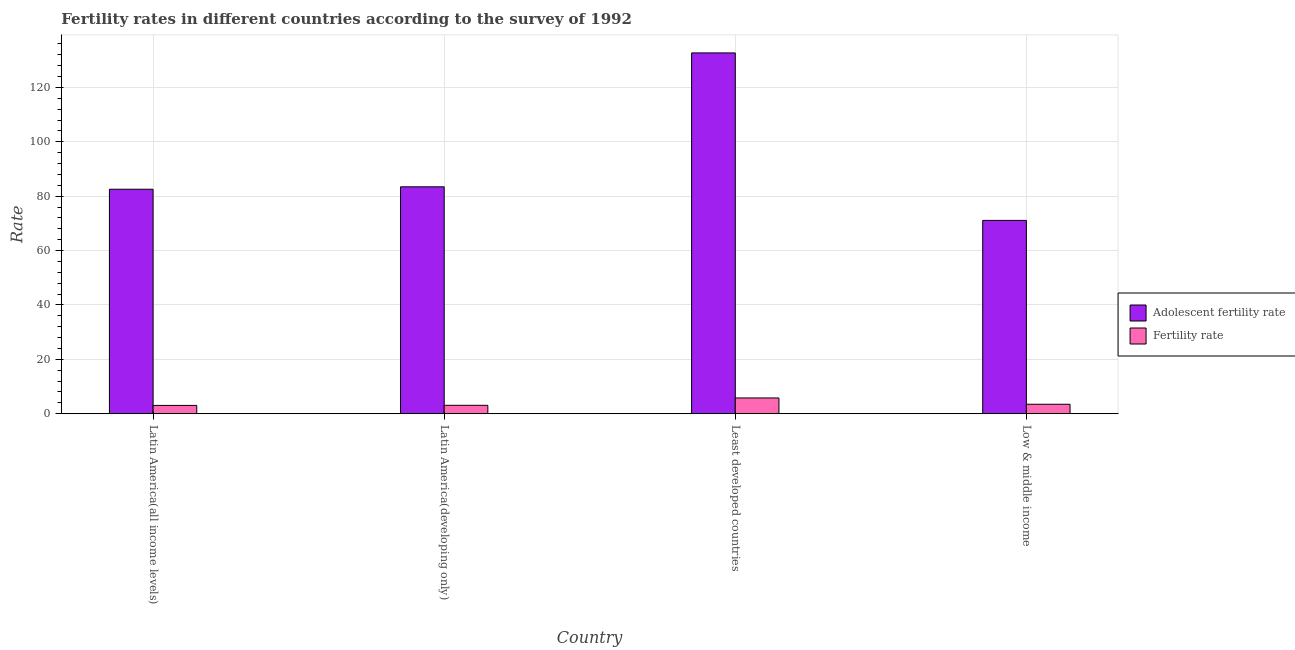Are the number of bars on each tick of the X-axis equal?
Provide a succinct answer. Yes. How many bars are there on the 3rd tick from the left?
Offer a terse response. 2. What is the label of the 2nd group of bars from the left?
Offer a very short reply. Latin America(developing only). In how many cases, is the number of bars for a given country not equal to the number of legend labels?
Give a very brief answer. 0. What is the adolescent fertility rate in Least developed countries?
Your response must be concise. 132.71. Across all countries, what is the maximum fertility rate?
Ensure brevity in your answer.  5.8. Across all countries, what is the minimum fertility rate?
Ensure brevity in your answer.  3.06. In which country was the fertility rate maximum?
Your response must be concise. Least developed countries. What is the total adolescent fertility rate in the graph?
Make the answer very short. 369.84. What is the difference between the fertility rate in Latin America(developing only) and that in Low & middle income?
Keep it short and to the point. -0.39. What is the difference between the adolescent fertility rate in Latin America(developing only) and the fertility rate in Low & middle income?
Ensure brevity in your answer.  79.97. What is the average adolescent fertility rate per country?
Give a very brief answer. 92.46. What is the difference between the fertility rate and adolescent fertility rate in Latin America(all income levels)?
Make the answer very short. -79.51. In how many countries, is the fertility rate greater than 40 ?
Provide a short and direct response. 0. What is the ratio of the fertility rate in Latin America(developing only) to that in Least developed countries?
Provide a succinct answer. 0.53. Is the fertility rate in Latin America(developing only) less than that in Least developed countries?
Provide a short and direct response. Yes. What is the difference between the highest and the second highest fertility rate?
Ensure brevity in your answer.  2.31. What is the difference between the highest and the lowest adolescent fertility rate?
Offer a very short reply. 61.6. Is the sum of the adolescent fertility rate in Latin America(developing only) and Least developed countries greater than the maximum fertility rate across all countries?
Your answer should be very brief. Yes. What does the 2nd bar from the left in Latin America(all income levels) represents?
Your answer should be compact. Fertility rate. What does the 1st bar from the right in Least developed countries represents?
Your answer should be very brief. Fertility rate. How many countries are there in the graph?
Your answer should be compact. 4. What is the difference between two consecutive major ticks on the Y-axis?
Your answer should be very brief. 20. Does the graph contain any zero values?
Provide a short and direct response. No. Does the graph contain grids?
Give a very brief answer. Yes. Where does the legend appear in the graph?
Your response must be concise. Center right. How many legend labels are there?
Offer a very short reply. 2. How are the legend labels stacked?
Make the answer very short. Vertical. What is the title of the graph?
Provide a short and direct response. Fertility rates in different countries according to the survey of 1992. Does "Formally registered" appear as one of the legend labels in the graph?
Offer a very short reply. No. What is the label or title of the X-axis?
Make the answer very short. Country. What is the label or title of the Y-axis?
Ensure brevity in your answer.  Rate. What is the Rate of Adolescent fertility rate in Latin America(all income levels)?
Provide a succinct answer. 82.57. What is the Rate in Fertility rate in Latin America(all income levels)?
Offer a very short reply. 3.06. What is the Rate in Adolescent fertility rate in Latin America(developing only)?
Provide a short and direct response. 83.46. What is the Rate in Fertility rate in Latin America(developing only)?
Give a very brief answer. 3.1. What is the Rate of Adolescent fertility rate in Least developed countries?
Offer a very short reply. 132.71. What is the Rate of Fertility rate in Least developed countries?
Keep it short and to the point. 5.8. What is the Rate in Adolescent fertility rate in Low & middle income?
Offer a terse response. 71.11. What is the Rate in Fertility rate in Low & middle income?
Your answer should be very brief. 3.49. Across all countries, what is the maximum Rate in Adolescent fertility rate?
Your response must be concise. 132.71. Across all countries, what is the maximum Rate of Fertility rate?
Your answer should be very brief. 5.8. Across all countries, what is the minimum Rate of Adolescent fertility rate?
Ensure brevity in your answer.  71.11. Across all countries, what is the minimum Rate of Fertility rate?
Offer a terse response. 3.06. What is the total Rate of Adolescent fertility rate in the graph?
Keep it short and to the point. 369.84. What is the total Rate in Fertility rate in the graph?
Offer a terse response. 15.45. What is the difference between the Rate in Adolescent fertility rate in Latin America(all income levels) and that in Latin America(developing only)?
Make the answer very short. -0.89. What is the difference between the Rate in Fertility rate in Latin America(all income levels) and that in Latin America(developing only)?
Give a very brief answer. -0.04. What is the difference between the Rate in Adolescent fertility rate in Latin America(all income levels) and that in Least developed countries?
Provide a succinct answer. -50.14. What is the difference between the Rate in Fertility rate in Latin America(all income levels) and that in Least developed countries?
Keep it short and to the point. -2.74. What is the difference between the Rate in Adolescent fertility rate in Latin America(all income levels) and that in Low & middle income?
Your response must be concise. 11.46. What is the difference between the Rate of Fertility rate in Latin America(all income levels) and that in Low & middle income?
Your answer should be compact. -0.43. What is the difference between the Rate of Adolescent fertility rate in Latin America(developing only) and that in Least developed countries?
Your response must be concise. -49.25. What is the difference between the Rate in Fertility rate in Latin America(developing only) and that in Least developed countries?
Provide a short and direct response. -2.7. What is the difference between the Rate in Adolescent fertility rate in Latin America(developing only) and that in Low & middle income?
Your response must be concise. 12.35. What is the difference between the Rate in Fertility rate in Latin America(developing only) and that in Low & middle income?
Offer a terse response. -0.39. What is the difference between the Rate of Adolescent fertility rate in Least developed countries and that in Low & middle income?
Your answer should be compact. 61.6. What is the difference between the Rate in Fertility rate in Least developed countries and that in Low & middle income?
Offer a terse response. 2.31. What is the difference between the Rate of Adolescent fertility rate in Latin America(all income levels) and the Rate of Fertility rate in Latin America(developing only)?
Provide a succinct answer. 79.47. What is the difference between the Rate of Adolescent fertility rate in Latin America(all income levels) and the Rate of Fertility rate in Least developed countries?
Keep it short and to the point. 76.76. What is the difference between the Rate in Adolescent fertility rate in Latin America(all income levels) and the Rate in Fertility rate in Low & middle income?
Offer a very short reply. 79.08. What is the difference between the Rate in Adolescent fertility rate in Latin America(developing only) and the Rate in Fertility rate in Least developed countries?
Offer a terse response. 77.66. What is the difference between the Rate of Adolescent fertility rate in Latin America(developing only) and the Rate of Fertility rate in Low & middle income?
Your response must be concise. 79.97. What is the difference between the Rate in Adolescent fertility rate in Least developed countries and the Rate in Fertility rate in Low & middle income?
Your response must be concise. 129.22. What is the average Rate in Adolescent fertility rate per country?
Your answer should be compact. 92.46. What is the average Rate of Fertility rate per country?
Ensure brevity in your answer.  3.86. What is the difference between the Rate of Adolescent fertility rate and Rate of Fertility rate in Latin America(all income levels)?
Offer a very short reply. 79.51. What is the difference between the Rate of Adolescent fertility rate and Rate of Fertility rate in Latin America(developing only)?
Provide a short and direct response. 80.36. What is the difference between the Rate in Adolescent fertility rate and Rate in Fertility rate in Least developed countries?
Keep it short and to the point. 126.9. What is the difference between the Rate of Adolescent fertility rate and Rate of Fertility rate in Low & middle income?
Your response must be concise. 67.62. What is the ratio of the Rate of Adolescent fertility rate in Latin America(all income levels) to that in Latin America(developing only)?
Your answer should be compact. 0.99. What is the ratio of the Rate of Fertility rate in Latin America(all income levels) to that in Latin America(developing only)?
Provide a succinct answer. 0.99. What is the ratio of the Rate in Adolescent fertility rate in Latin America(all income levels) to that in Least developed countries?
Offer a very short reply. 0.62. What is the ratio of the Rate in Fertility rate in Latin America(all income levels) to that in Least developed countries?
Your answer should be compact. 0.53. What is the ratio of the Rate of Adolescent fertility rate in Latin America(all income levels) to that in Low & middle income?
Ensure brevity in your answer.  1.16. What is the ratio of the Rate in Fertility rate in Latin America(all income levels) to that in Low & middle income?
Ensure brevity in your answer.  0.88. What is the ratio of the Rate in Adolescent fertility rate in Latin America(developing only) to that in Least developed countries?
Ensure brevity in your answer.  0.63. What is the ratio of the Rate in Fertility rate in Latin America(developing only) to that in Least developed countries?
Offer a very short reply. 0.53. What is the ratio of the Rate of Adolescent fertility rate in Latin America(developing only) to that in Low & middle income?
Make the answer very short. 1.17. What is the ratio of the Rate of Fertility rate in Latin America(developing only) to that in Low & middle income?
Keep it short and to the point. 0.89. What is the ratio of the Rate in Adolescent fertility rate in Least developed countries to that in Low & middle income?
Give a very brief answer. 1.87. What is the ratio of the Rate in Fertility rate in Least developed countries to that in Low & middle income?
Make the answer very short. 1.66. What is the difference between the highest and the second highest Rate of Adolescent fertility rate?
Ensure brevity in your answer.  49.25. What is the difference between the highest and the second highest Rate of Fertility rate?
Ensure brevity in your answer.  2.31. What is the difference between the highest and the lowest Rate in Adolescent fertility rate?
Provide a succinct answer. 61.6. What is the difference between the highest and the lowest Rate in Fertility rate?
Provide a succinct answer. 2.74. 